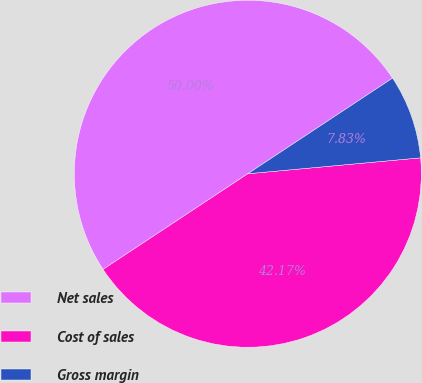<chart> <loc_0><loc_0><loc_500><loc_500><pie_chart><fcel>Net sales<fcel>Cost of sales<fcel>Gross margin<nl><fcel>50.0%<fcel>42.17%<fcel>7.83%<nl></chart> 